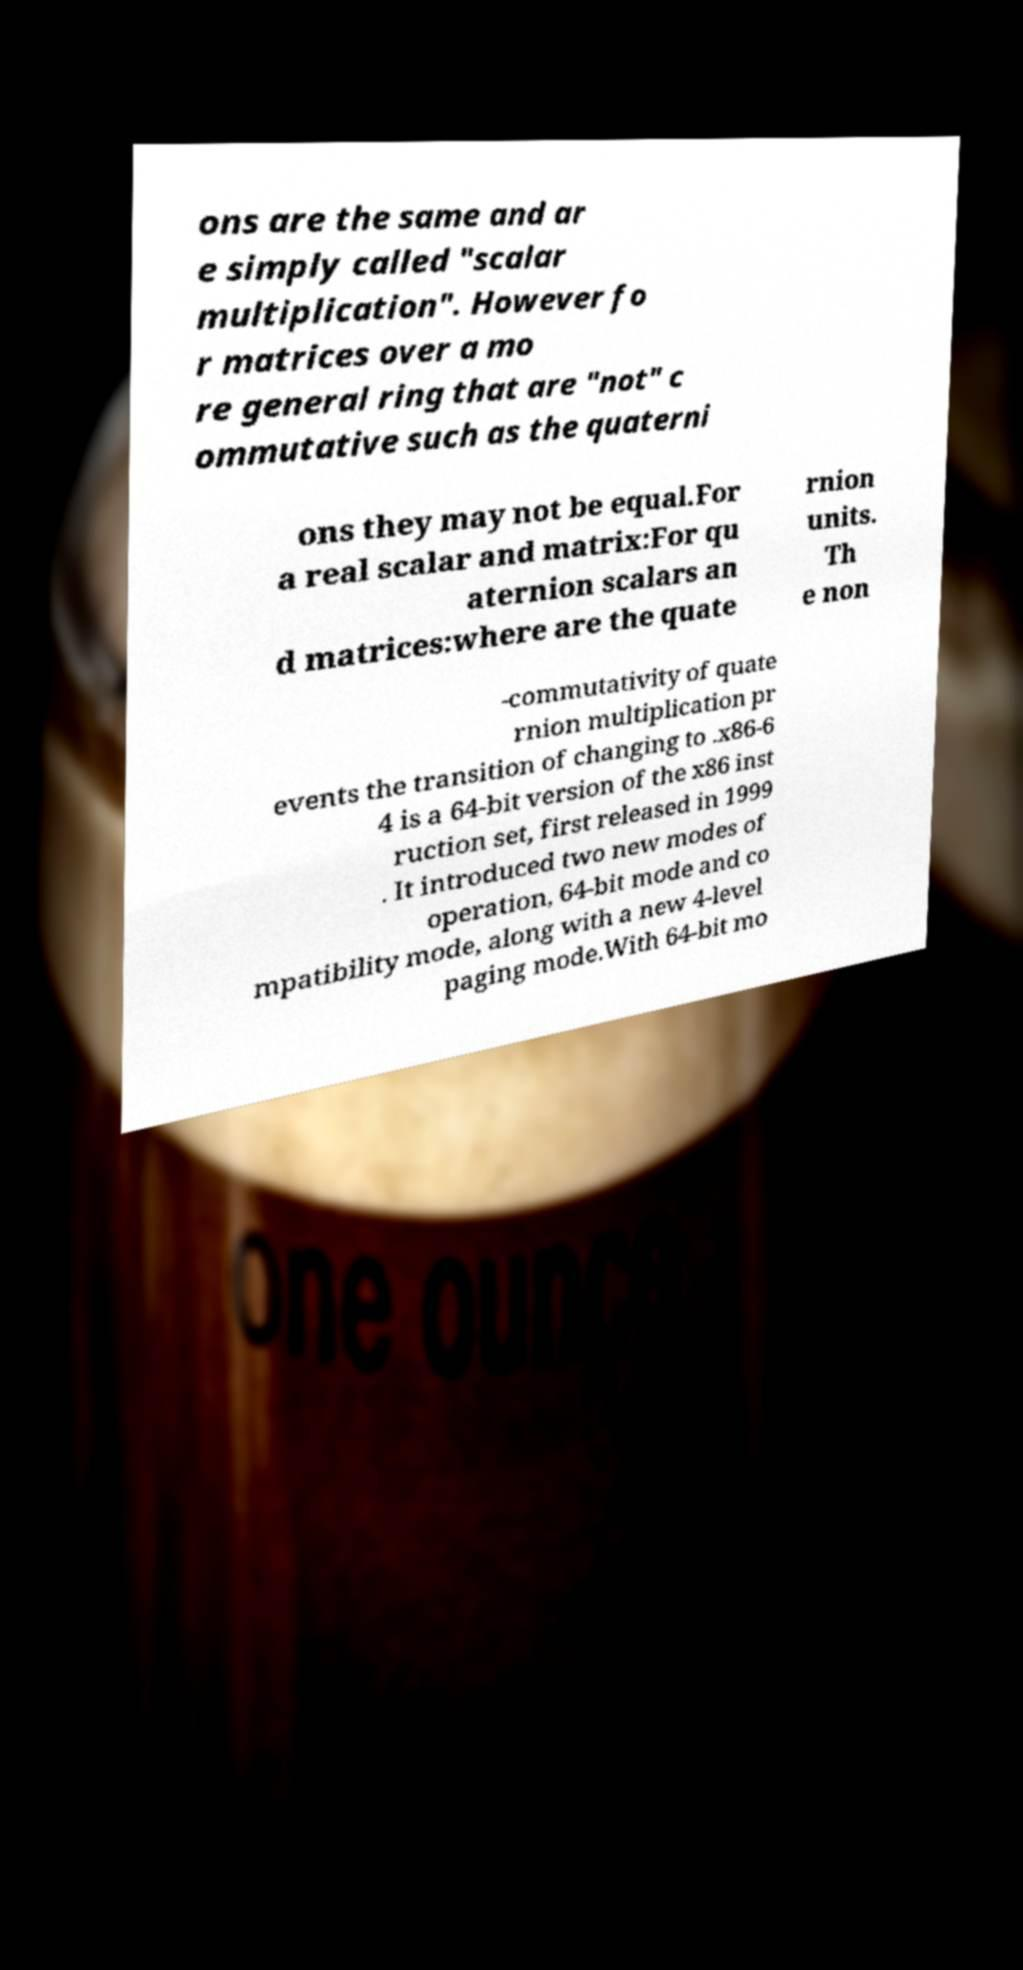For documentation purposes, I need the text within this image transcribed. Could you provide that? ons are the same and ar e simply called "scalar multiplication". However fo r matrices over a mo re general ring that are "not" c ommutative such as the quaterni ons they may not be equal.For a real scalar and matrix:For qu aternion scalars an d matrices:where are the quate rnion units. Th e non -commutativity of quate rnion multiplication pr events the transition of changing to .x86-6 4 is a 64-bit version of the x86 inst ruction set, first released in 1999 . It introduced two new modes of operation, 64-bit mode and co mpatibility mode, along with a new 4-level paging mode.With 64-bit mo 